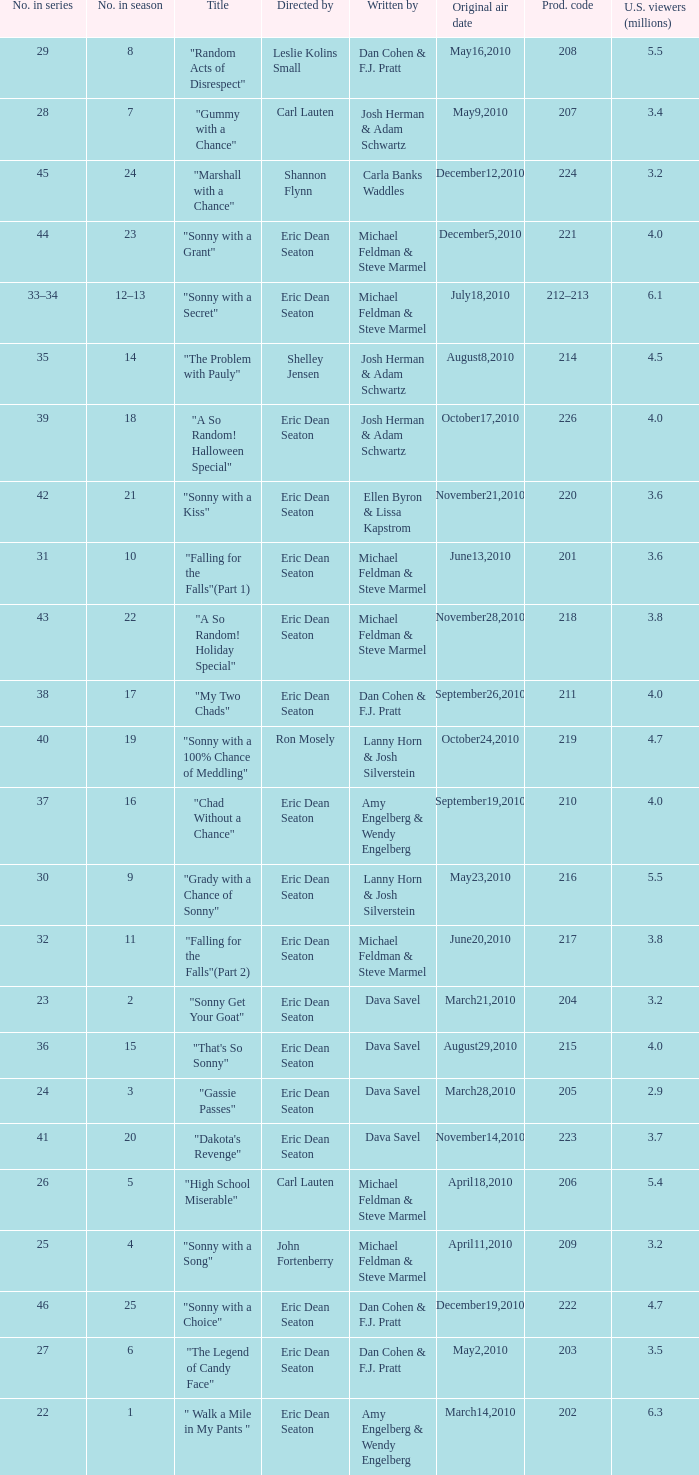Who directed the episode that 6.3 million u.s. viewers saw? Eric Dean Seaton. 